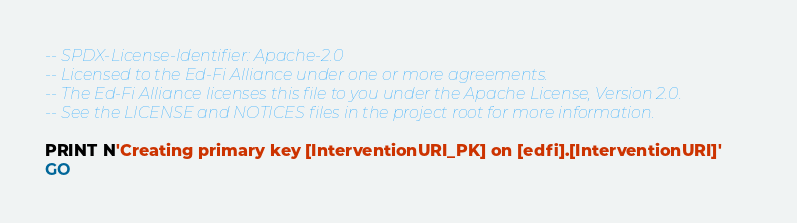Convert code to text. <code><loc_0><loc_0><loc_500><loc_500><_SQL_>-- SPDX-License-Identifier: Apache-2.0
-- Licensed to the Ed-Fi Alliance under one or more agreements.
-- The Ed-Fi Alliance licenses this file to you under the Apache License, Version 2.0.
-- See the LICENSE and NOTICES files in the project root for more information.

PRINT N'Creating primary key [InterventionURI_PK] on [edfi].[InterventionURI]'
GO</code> 